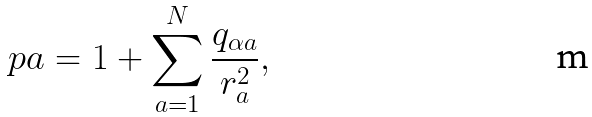<formula> <loc_0><loc_0><loc_500><loc_500>\ p a = 1 + \sum _ { a = 1 } ^ { N } \frac { q _ { \alpha a } } { r _ { a } ^ { 2 } } ,</formula> 